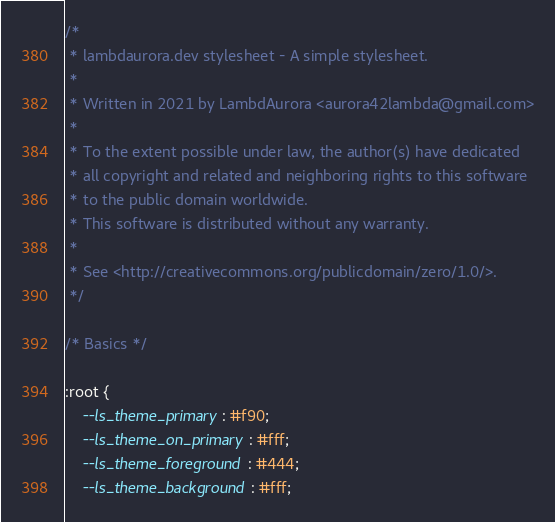Convert code to text. <code><loc_0><loc_0><loc_500><loc_500><_CSS_>/*
 * lambdaurora.dev stylesheet - A simple stylesheet.
 *
 * Written in 2021 by LambdAurora <aurora42lambda@gmail.com>
 *
 * To the extent possible under law, the author(s) have dedicated
 * all copyright and related and neighboring rights to this software
 * to the public domain worldwide.
 * This software is distributed without any warranty.
 *
 * See <http://creativecommons.org/publicdomain/zero/1.0/>.
 */

/* Basics */

:root {
	--ls_theme_primary: #f90;
	--ls_theme_on_primary: #fff;
	--ls_theme_foreground: #444;
	--ls_theme_background: #fff;
</code> 